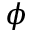Convert formula to latex. <formula><loc_0><loc_0><loc_500><loc_500>\phi</formula> 